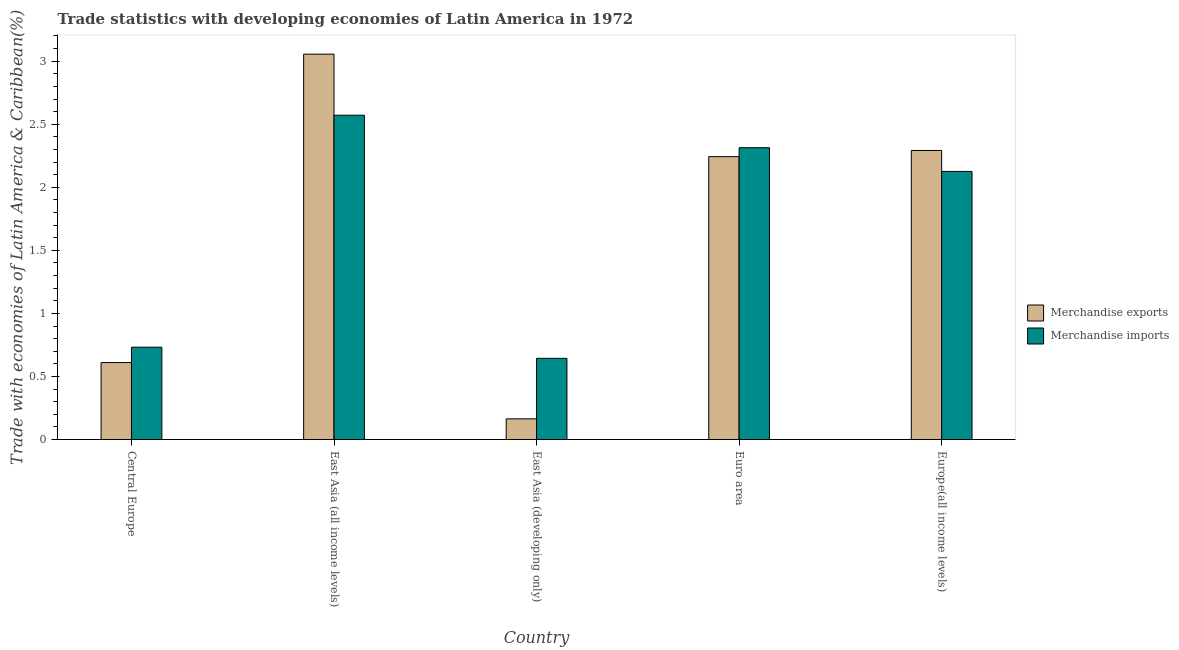How many groups of bars are there?
Ensure brevity in your answer.  5. Are the number of bars on each tick of the X-axis equal?
Provide a short and direct response. Yes. How many bars are there on the 4th tick from the left?
Keep it short and to the point. 2. What is the label of the 4th group of bars from the left?
Your response must be concise. Euro area. What is the merchandise imports in Euro area?
Provide a short and direct response. 2.31. Across all countries, what is the maximum merchandise imports?
Provide a succinct answer. 2.57. Across all countries, what is the minimum merchandise imports?
Offer a terse response. 0.64. In which country was the merchandise imports maximum?
Your answer should be very brief. East Asia (all income levels). In which country was the merchandise exports minimum?
Offer a very short reply. East Asia (developing only). What is the total merchandise exports in the graph?
Make the answer very short. 8.37. What is the difference between the merchandise exports in Central Europe and that in Euro area?
Ensure brevity in your answer.  -1.63. What is the difference between the merchandise exports in East Asia (developing only) and the merchandise imports in Central Europe?
Make the answer very short. -0.57. What is the average merchandise exports per country?
Offer a very short reply. 1.67. What is the difference between the merchandise imports and merchandise exports in Euro area?
Offer a terse response. 0.07. In how many countries, is the merchandise imports greater than 2.4 %?
Provide a short and direct response. 1. What is the ratio of the merchandise imports in Central Europe to that in East Asia (developing only)?
Keep it short and to the point. 1.14. Is the difference between the merchandise imports in Central Europe and East Asia (developing only) greater than the difference between the merchandise exports in Central Europe and East Asia (developing only)?
Offer a very short reply. No. What is the difference between the highest and the second highest merchandise exports?
Give a very brief answer. 0.76. What is the difference between the highest and the lowest merchandise exports?
Your response must be concise. 2.89. Is the sum of the merchandise imports in East Asia (all income levels) and Europe(all income levels) greater than the maximum merchandise exports across all countries?
Make the answer very short. Yes. What does the 2nd bar from the left in East Asia (developing only) represents?
Keep it short and to the point. Merchandise imports. What does the 1st bar from the right in Euro area represents?
Provide a succinct answer. Merchandise imports. How many bars are there?
Give a very brief answer. 10. How many countries are there in the graph?
Provide a short and direct response. 5. Does the graph contain any zero values?
Offer a very short reply. No. How many legend labels are there?
Offer a terse response. 2. What is the title of the graph?
Offer a terse response. Trade statistics with developing economies of Latin America in 1972. Does "Sanitation services" appear as one of the legend labels in the graph?
Provide a short and direct response. No. What is the label or title of the Y-axis?
Your response must be concise. Trade with economies of Latin America & Caribbean(%). What is the Trade with economies of Latin America & Caribbean(%) of Merchandise exports in Central Europe?
Give a very brief answer. 0.61. What is the Trade with economies of Latin America & Caribbean(%) in Merchandise imports in Central Europe?
Provide a succinct answer. 0.73. What is the Trade with economies of Latin America & Caribbean(%) in Merchandise exports in East Asia (all income levels)?
Make the answer very short. 3.06. What is the Trade with economies of Latin America & Caribbean(%) in Merchandise imports in East Asia (all income levels)?
Offer a very short reply. 2.57. What is the Trade with economies of Latin America & Caribbean(%) of Merchandise exports in East Asia (developing only)?
Provide a succinct answer. 0.16. What is the Trade with economies of Latin America & Caribbean(%) of Merchandise imports in East Asia (developing only)?
Your response must be concise. 0.64. What is the Trade with economies of Latin America & Caribbean(%) of Merchandise exports in Euro area?
Your answer should be very brief. 2.24. What is the Trade with economies of Latin America & Caribbean(%) of Merchandise imports in Euro area?
Ensure brevity in your answer.  2.31. What is the Trade with economies of Latin America & Caribbean(%) of Merchandise exports in Europe(all income levels)?
Your answer should be very brief. 2.29. What is the Trade with economies of Latin America & Caribbean(%) in Merchandise imports in Europe(all income levels)?
Offer a very short reply. 2.13. Across all countries, what is the maximum Trade with economies of Latin America & Caribbean(%) in Merchandise exports?
Keep it short and to the point. 3.06. Across all countries, what is the maximum Trade with economies of Latin America & Caribbean(%) in Merchandise imports?
Your answer should be compact. 2.57. Across all countries, what is the minimum Trade with economies of Latin America & Caribbean(%) in Merchandise exports?
Provide a succinct answer. 0.16. Across all countries, what is the minimum Trade with economies of Latin America & Caribbean(%) in Merchandise imports?
Make the answer very short. 0.64. What is the total Trade with economies of Latin America & Caribbean(%) in Merchandise exports in the graph?
Your answer should be compact. 8.37. What is the total Trade with economies of Latin America & Caribbean(%) in Merchandise imports in the graph?
Keep it short and to the point. 8.39. What is the difference between the Trade with economies of Latin America & Caribbean(%) in Merchandise exports in Central Europe and that in East Asia (all income levels)?
Ensure brevity in your answer.  -2.45. What is the difference between the Trade with economies of Latin America & Caribbean(%) in Merchandise imports in Central Europe and that in East Asia (all income levels)?
Give a very brief answer. -1.84. What is the difference between the Trade with economies of Latin America & Caribbean(%) in Merchandise exports in Central Europe and that in East Asia (developing only)?
Provide a short and direct response. 0.45. What is the difference between the Trade with economies of Latin America & Caribbean(%) in Merchandise imports in Central Europe and that in East Asia (developing only)?
Ensure brevity in your answer.  0.09. What is the difference between the Trade with economies of Latin America & Caribbean(%) of Merchandise exports in Central Europe and that in Euro area?
Your response must be concise. -1.63. What is the difference between the Trade with economies of Latin America & Caribbean(%) of Merchandise imports in Central Europe and that in Euro area?
Offer a terse response. -1.58. What is the difference between the Trade with economies of Latin America & Caribbean(%) in Merchandise exports in Central Europe and that in Europe(all income levels)?
Make the answer very short. -1.68. What is the difference between the Trade with economies of Latin America & Caribbean(%) of Merchandise imports in Central Europe and that in Europe(all income levels)?
Your answer should be very brief. -1.39. What is the difference between the Trade with economies of Latin America & Caribbean(%) in Merchandise exports in East Asia (all income levels) and that in East Asia (developing only)?
Offer a terse response. 2.89. What is the difference between the Trade with economies of Latin America & Caribbean(%) in Merchandise imports in East Asia (all income levels) and that in East Asia (developing only)?
Give a very brief answer. 1.93. What is the difference between the Trade with economies of Latin America & Caribbean(%) in Merchandise exports in East Asia (all income levels) and that in Euro area?
Keep it short and to the point. 0.81. What is the difference between the Trade with economies of Latin America & Caribbean(%) in Merchandise imports in East Asia (all income levels) and that in Euro area?
Provide a short and direct response. 0.26. What is the difference between the Trade with economies of Latin America & Caribbean(%) of Merchandise exports in East Asia (all income levels) and that in Europe(all income levels)?
Your answer should be very brief. 0.76. What is the difference between the Trade with economies of Latin America & Caribbean(%) of Merchandise imports in East Asia (all income levels) and that in Europe(all income levels)?
Keep it short and to the point. 0.45. What is the difference between the Trade with economies of Latin America & Caribbean(%) in Merchandise exports in East Asia (developing only) and that in Euro area?
Provide a succinct answer. -2.08. What is the difference between the Trade with economies of Latin America & Caribbean(%) of Merchandise imports in East Asia (developing only) and that in Euro area?
Offer a very short reply. -1.67. What is the difference between the Trade with economies of Latin America & Caribbean(%) in Merchandise exports in East Asia (developing only) and that in Europe(all income levels)?
Give a very brief answer. -2.13. What is the difference between the Trade with economies of Latin America & Caribbean(%) of Merchandise imports in East Asia (developing only) and that in Europe(all income levels)?
Make the answer very short. -1.48. What is the difference between the Trade with economies of Latin America & Caribbean(%) of Merchandise exports in Euro area and that in Europe(all income levels)?
Offer a very short reply. -0.05. What is the difference between the Trade with economies of Latin America & Caribbean(%) of Merchandise imports in Euro area and that in Europe(all income levels)?
Provide a short and direct response. 0.19. What is the difference between the Trade with economies of Latin America & Caribbean(%) in Merchandise exports in Central Europe and the Trade with economies of Latin America & Caribbean(%) in Merchandise imports in East Asia (all income levels)?
Give a very brief answer. -1.96. What is the difference between the Trade with economies of Latin America & Caribbean(%) of Merchandise exports in Central Europe and the Trade with economies of Latin America & Caribbean(%) of Merchandise imports in East Asia (developing only)?
Make the answer very short. -0.03. What is the difference between the Trade with economies of Latin America & Caribbean(%) of Merchandise exports in Central Europe and the Trade with economies of Latin America & Caribbean(%) of Merchandise imports in Euro area?
Ensure brevity in your answer.  -1.7. What is the difference between the Trade with economies of Latin America & Caribbean(%) in Merchandise exports in Central Europe and the Trade with economies of Latin America & Caribbean(%) in Merchandise imports in Europe(all income levels)?
Provide a succinct answer. -1.52. What is the difference between the Trade with economies of Latin America & Caribbean(%) of Merchandise exports in East Asia (all income levels) and the Trade with economies of Latin America & Caribbean(%) of Merchandise imports in East Asia (developing only)?
Your answer should be compact. 2.41. What is the difference between the Trade with economies of Latin America & Caribbean(%) in Merchandise exports in East Asia (all income levels) and the Trade with economies of Latin America & Caribbean(%) in Merchandise imports in Euro area?
Your answer should be compact. 0.74. What is the difference between the Trade with economies of Latin America & Caribbean(%) of Merchandise exports in East Asia (developing only) and the Trade with economies of Latin America & Caribbean(%) of Merchandise imports in Euro area?
Offer a terse response. -2.15. What is the difference between the Trade with economies of Latin America & Caribbean(%) in Merchandise exports in East Asia (developing only) and the Trade with economies of Latin America & Caribbean(%) in Merchandise imports in Europe(all income levels)?
Provide a succinct answer. -1.96. What is the difference between the Trade with economies of Latin America & Caribbean(%) in Merchandise exports in Euro area and the Trade with economies of Latin America & Caribbean(%) in Merchandise imports in Europe(all income levels)?
Offer a terse response. 0.12. What is the average Trade with economies of Latin America & Caribbean(%) in Merchandise exports per country?
Give a very brief answer. 1.67. What is the average Trade with economies of Latin America & Caribbean(%) in Merchandise imports per country?
Your response must be concise. 1.68. What is the difference between the Trade with economies of Latin America & Caribbean(%) of Merchandise exports and Trade with economies of Latin America & Caribbean(%) of Merchandise imports in Central Europe?
Keep it short and to the point. -0.12. What is the difference between the Trade with economies of Latin America & Caribbean(%) in Merchandise exports and Trade with economies of Latin America & Caribbean(%) in Merchandise imports in East Asia (all income levels)?
Provide a short and direct response. 0.48. What is the difference between the Trade with economies of Latin America & Caribbean(%) of Merchandise exports and Trade with economies of Latin America & Caribbean(%) of Merchandise imports in East Asia (developing only)?
Provide a short and direct response. -0.48. What is the difference between the Trade with economies of Latin America & Caribbean(%) of Merchandise exports and Trade with economies of Latin America & Caribbean(%) of Merchandise imports in Euro area?
Provide a short and direct response. -0.07. What is the difference between the Trade with economies of Latin America & Caribbean(%) of Merchandise exports and Trade with economies of Latin America & Caribbean(%) of Merchandise imports in Europe(all income levels)?
Your answer should be very brief. 0.17. What is the ratio of the Trade with economies of Latin America & Caribbean(%) of Merchandise exports in Central Europe to that in East Asia (all income levels)?
Make the answer very short. 0.2. What is the ratio of the Trade with economies of Latin America & Caribbean(%) of Merchandise imports in Central Europe to that in East Asia (all income levels)?
Keep it short and to the point. 0.28. What is the ratio of the Trade with economies of Latin America & Caribbean(%) of Merchandise exports in Central Europe to that in East Asia (developing only)?
Give a very brief answer. 3.73. What is the ratio of the Trade with economies of Latin America & Caribbean(%) in Merchandise imports in Central Europe to that in East Asia (developing only)?
Your answer should be compact. 1.14. What is the ratio of the Trade with economies of Latin America & Caribbean(%) of Merchandise exports in Central Europe to that in Euro area?
Provide a short and direct response. 0.27. What is the ratio of the Trade with economies of Latin America & Caribbean(%) of Merchandise imports in Central Europe to that in Euro area?
Give a very brief answer. 0.32. What is the ratio of the Trade with economies of Latin America & Caribbean(%) in Merchandise exports in Central Europe to that in Europe(all income levels)?
Offer a very short reply. 0.27. What is the ratio of the Trade with economies of Latin America & Caribbean(%) of Merchandise imports in Central Europe to that in Europe(all income levels)?
Keep it short and to the point. 0.34. What is the ratio of the Trade with economies of Latin America & Caribbean(%) of Merchandise exports in East Asia (all income levels) to that in East Asia (developing only)?
Your response must be concise. 18.66. What is the ratio of the Trade with economies of Latin America & Caribbean(%) in Merchandise imports in East Asia (all income levels) to that in East Asia (developing only)?
Your answer should be compact. 3.99. What is the ratio of the Trade with economies of Latin America & Caribbean(%) of Merchandise exports in East Asia (all income levels) to that in Euro area?
Your answer should be compact. 1.36. What is the ratio of the Trade with economies of Latin America & Caribbean(%) of Merchandise imports in East Asia (all income levels) to that in Euro area?
Provide a short and direct response. 1.11. What is the ratio of the Trade with economies of Latin America & Caribbean(%) of Merchandise exports in East Asia (all income levels) to that in Europe(all income levels)?
Make the answer very short. 1.33. What is the ratio of the Trade with economies of Latin America & Caribbean(%) in Merchandise imports in East Asia (all income levels) to that in Europe(all income levels)?
Give a very brief answer. 1.21. What is the ratio of the Trade with economies of Latin America & Caribbean(%) in Merchandise exports in East Asia (developing only) to that in Euro area?
Offer a very short reply. 0.07. What is the ratio of the Trade with economies of Latin America & Caribbean(%) of Merchandise imports in East Asia (developing only) to that in Euro area?
Your response must be concise. 0.28. What is the ratio of the Trade with economies of Latin America & Caribbean(%) of Merchandise exports in East Asia (developing only) to that in Europe(all income levels)?
Your response must be concise. 0.07. What is the ratio of the Trade with economies of Latin America & Caribbean(%) of Merchandise imports in East Asia (developing only) to that in Europe(all income levels)?
Your answer should be compact. 0.3. What is the ratio of the Trade with economies of Latin America & Caribbean(%) of Merchandise exports in Euro area to that in Europe(all income levels)?
Provide a succinct answer. 0.98. What is the ratio of the Trade with economies of Latin America & Caribbean(%) in Merchandise imports in Euro area to that in Europe(all income levels)?
Keep it short and to the point. 1.09. What is the difference between the highest and the second highest Trade with economies of Latin America & Caribbean(%) in Merchandise exports?
Keep it short and to the point. 0.76. What is the difference between the highest and the second highest Trade with economies of Latin America & Caribbean(%) of Merchandise imports?
Your answer should be compact. 0.26. What is the difference between the highest and the lowest Trade with economies of Latin America & Caribbean(%) in Merchandise exports?
Offer a very short reply. 2.89. What is the difference between the highest and the lowest Trade with economies of Latin America & Caribbean(%) in Merchandise imports?
Your response must be concise. 1.93. 